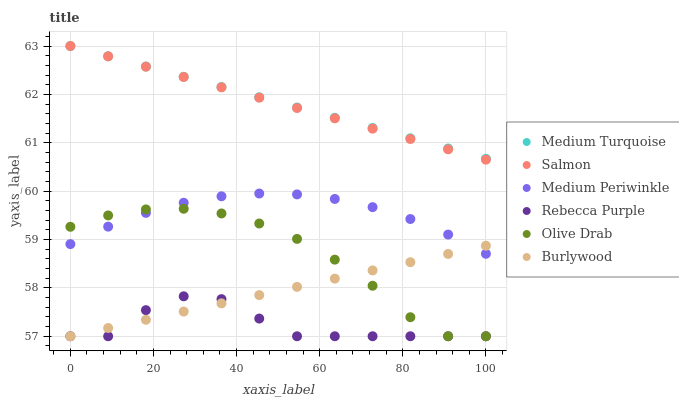Does Rebecca Purple have the minimum area under the curve?
Answer yes or no. Yes. Does Medium Turquoise have the maximum area under the curve?
Answer yes or no. Yes. Does Salmon have the minimum area under the curve?
Answer yes or no. No. Does Salmon have the maximum area under the curve?
Answer yes or no. No. Is Salmon the smoothest?
Answer yes or no. Yes. Is Rebecca Purple the roughest?
Answer yes or no. Yes. Is Medium Periwinkle the smoothest?
Answer yes or no. No. Is Medium Periwinkle the roughest?
Answer yes or no. No. Does Burlywood have the lowest value?
Answer yes or no. Yes. Does Salmon have the lowest value?
Answer yes or no. No. Does Medium Turquoise have the highest value?
Answer yes or no. Yes. Does Medium Periwinkle have the highest value?
Answer yes or no. No. Is Burlywood less than Medium Turquoise?
Answer yes or no. Yes. Is Salmon greater than Burlywood?
Answer yes or no. Yes. Does Rebecca Purple intersect Burlywood?
Answer yes or no. Yes. Is Rebecca Purple less than Burlywood?
Answer yes or no. No. Is Rebecca Purple greater than Burlywood?
Answer yes or no. No. Does Burlywood intersect Medium Turquoise?
Answer yes or no. No. 